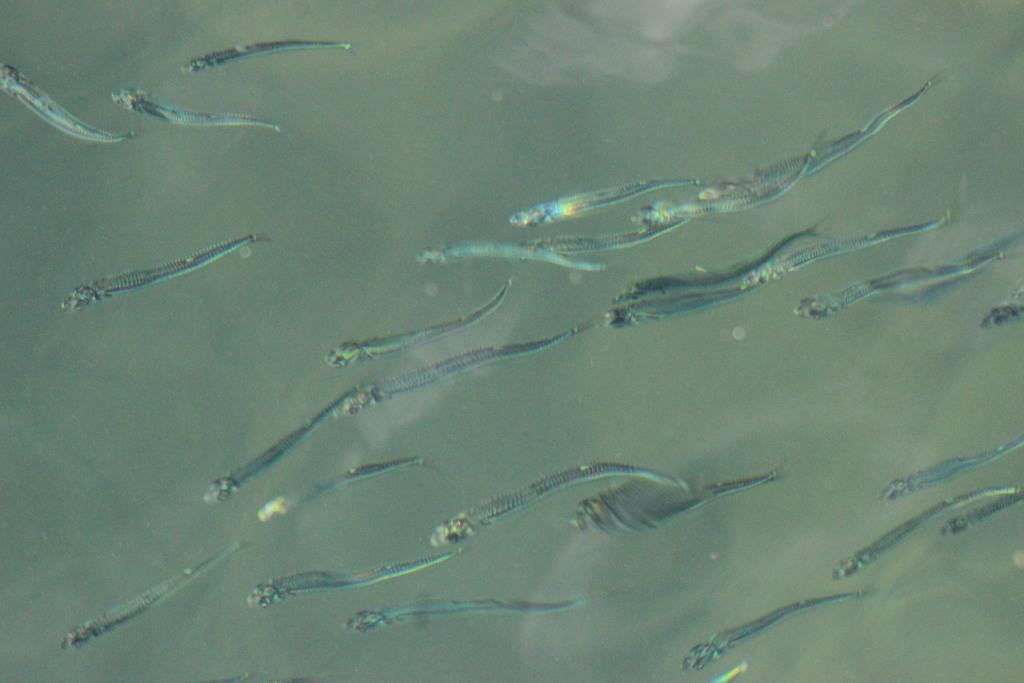What is the main subject of the image? The main subject of the image is a close view of fish. Where are the fish located in the image? The fish are underwater in the image. What type of stocking is covering the fish in the image? There is no stocking covering the fish in the image; they are underwater and not wearing any clothing. 